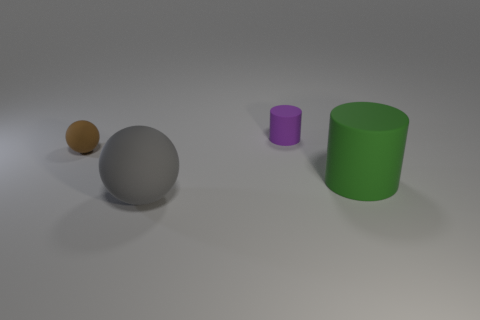There is another matte object that is the same shape as the green rubber thing; what is its size?
Provide a succinct answer. Small. There is a tiny rubber object in front of the purple matte object; what number of large green cylinders are right of it?
Give a very brief answer. 1. There is a big matte sphere; is it the same color as the sphere behind the big rubber cylinder?
Give a very brief answer. No. The matte cylinder that is the same size as the brown ball is what color?
Provide a short and direct response. Purple. Are there any large objects of the same shape as the tiny brown object?
Your answer should be compact. Yes. Is the number of large gray rubber objects less than the number of small metal spheres?
Provide a short and direct response. No. What color is the cylinder that is on the right side of the small purple thing?
Give a very brief answer. Green. There is a tiny rubber thing that is on the right side of the small thing that is left of the tiny purple cylinder; what shape is it?
Ensure brevity in your answer.  Cylinder. Are the large gray thing and the tiny thing that is in front of the tiny cylinder made of the same material?
Make the answer very short. Yes. How many gray rubber balls have the same size as the brown ball?
Make the answer very short. 0. 